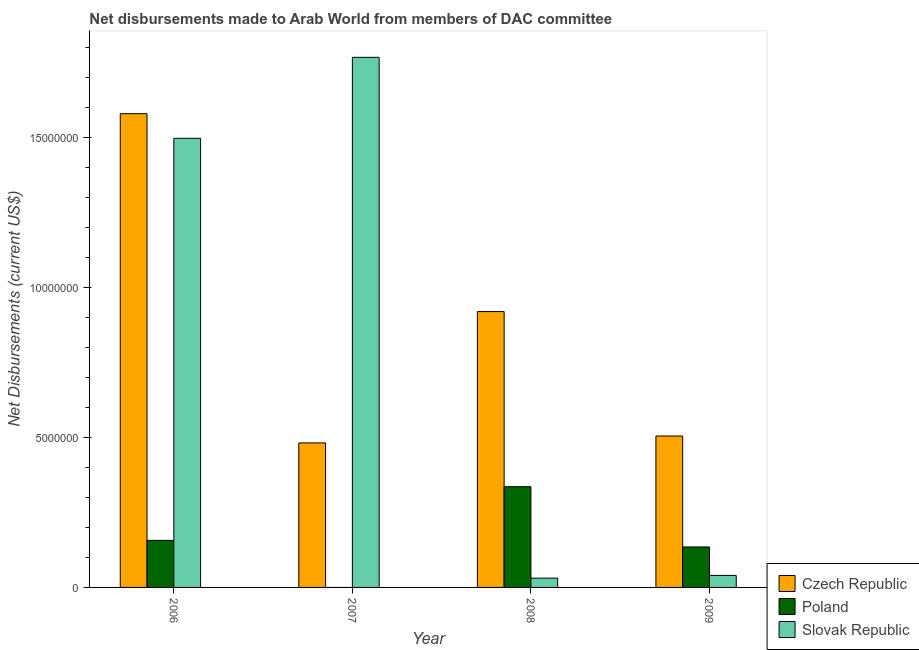How many different coloured bars are there?
Ensure brevity in your answer.  3. How many bars are there on the 3rd tick from the left?
Give a very brief answer. 3. How many bars are there on the 1st tick from the right?
Your answer should be very brief. 3. What is the label of the 3rd group of bars from the left?
Give a very brief answer. 2008. Across all years, what is the maximum net disbursements made by slovak republic?
Offer a very short reply. 1.77e+07. Across all years, what is the minimum net disbursements made by poland?
Provide a succinct answer. 0. In which year was the net disbursements made by czech republic maximum?
Keep it short and to the point. 2006. What is the total net disbursements made by czech republic in the graph?
Your response must be concise. 3.49e+07. What is the difference between the net disbursements made by slovak republic in 2007 and that in 2008?
Offer a very short reply. 1.74e+07. What is the difference between the net disbursements made by slovak republic in 2006 and the net disbursements made by poland in 2008?
Offer a terse response. 1.47e+07. What is the average net disbursements made by czech republic per year?
Ensure brevity in your answer.  8.72e+06. What is the ratio of the net disbursements made by slovak republic in 2006 to that in 2007?
Provide a succinct answer. 0.85. Is the net disbursements made by slovak republic in 2006 less than that in 2009?
Give a very brief answer. No. Is the difference between the net disbursements made by czech republic in 2006 and 2009 greater than the difference between the net disbursements made by slovak republic in 2006 and 2009?
Offer a terse response. No. What is the difference between the highest and the second highest net disbursements made by slovak republic?
Ensure brevity in your answer.  2.70e+06. What is the difference between the highest and the lowest net disbursements made by slovak republic?
Give a very brief answer. 1.74e+07. In how many years, is the net disbursements made by czech republic greater than the average net disbursements made by czech republic taken over all years?
Offer a very short reply. 2. Is the sum of the net disbursements made by slovak republic in 2006 and 2007 greater than the maximum net disbursements made by poland across all years?
Your answer should be compact. Yes. Are all the bars in the graph horizontal?
Provide a short and direct response. No. How many years are there in the graph?
Ensure brevity in your answer.  4. Are the values on the major ticks of Y-axis written in scientific E-notation?
Provide a succinct answer. No. Does the graph contain any zero values?
Your answer should be compact. Yes. Does the graph contain grids?
Your answer should be very brief. No. What is the title of the graph?
Keep it short and to the point. Net disbursements made to Arab World from members of DAC committee. What is the label or title of the Y-axis?
Ensure brevity in your answer.  Net Disbursements (current US$). What is the Net Disbursements (current US$) in Czech Republic in 2006?
Your answer should be very brief. 1.58e+07. What is the Net Disbursements (current US$) in Poland in 2006?
Provide a succinct answer. 1.57e+06. What is the Net Disbursements (current US$) of Slovak Republic in 2006?
Your answer should be compact. 1.50e+07. What is the Net Disbursements (current US$) in Czech Republic in 2007?
Your answer should be very brief. 4.82e+06. What is the Net Disbursements (current US$) in Poland in 2007?
Give a very brief answer. 0. What is the Net Disbursements (current US$) of Slovak Republic in 2007?
Your answer should be compact. 1.77e+07. What is the Net Disbursements (current US$) in Czech Republic in 2008?
Keep it short and to the point. 9.20e+06. What is the Net Disbursements (current US$) in Poland in 2008?
Provide a succinct answer. 3.36e+06. What is the Net Disbursements (current US$) of Slovak Republic in 2008?
Offer a very short reply. 3.10e+05. What is the Net Disbursements (current US$) in Czech Republic in 2009?
Your response must be concise. 5.05e+06. What is the Net Disbursements (current US$) of Poland in 2009?
Make the answer very short. 1.35e+06. Across all years, what is the maximum Net Disbursements (current US$) of Czech Republic?
Ensure brevity in your answer.  1.58e+07. Across all years, what is the maximum Net Disbursements (current US$) of Poland?
Provide a succinct answer. 3.36e+06. Across all years, what is the maximum Net Disbursements (current US$) of Slovak Republic?
Your answer should be compact. 1.77e+07. Across all years, what is the minimum Net Disbursements (current US$) of Czech Republic?
Make the answer very short. 4.82e+06. Across all years, what is the minimum Net Disbursements (current US$) of Slovak Republic?
Your answer should be compact. 3.10e+05. What is the total Net Disbursements (current US$) of Czech Republic in the graph?
Offer a terse response. 3.49e+07. What is the total Net Disbursements (current US$) of Poland in the graph?
Make the answer very short. 6.28e+06. What is the total Net Disbursements (current US$) of Slovak Republic in the graph?
Keep it short and to the point. 3.34e+07. What is the difference between the Net Disbursements (current US$) of Czech Republic in 2006 and that in 2007?
Ensure brevity in your answer.  1.10e+07. What is the difference between the Net Disbursements (current US$) in Slovak Republic in 2006 and that in 2007?
Provide a short and direct response. -2.70e+06. What is the difference between the Net Disbursements (current US$) in Czech Republic in 2006 and that in 2008?
Make the answer very short. 6.60e+06. What is the difference between the Net Disbursements (current US$) in Poland in 2006 and that in 2008?
Provide a succinct answer. -1.79e+06. What is the difference between the Net Disbursements (current US$) in Slovak Republic in 2006 and that in 2008?
Keep it short and to the point. 1.47e+07. What is the difference between the Net Disbursements (current US$) of Czech Republic in 2006 and that in 2009?
Keep it short and to the point. 1.08e+07. What is the difference between the Net Disbursements (current US$) in Poland in 2006 and that in 2009?
Ensure brevity in your answer.  2.20e+05. What is the difference between the Net Disbursements (current US$) of Slovak Republic in 2006 and that in 2009?
Provide a short and direct response. 1.46e+07. What is the difference between the Net Disbursements (current US$) of Czech Republic in 2007 and that in 2008?
Offer a terse response. -4.38e+06. What is the difference between the Net Disbursements (current US$) of Slovak Republic in 2007 and that in 2008?
Ensure brevity in your answer.  1.74e+07. What is the difference between the Net Disbursements (current US$) in Slovak Republic in 2007 and that in 2009?
Offer a very short reply. 1.73e+07. What is the difference between the Net Disbursements (current US$) in Czech Republic in 2008 and that in 2009?
Make the answer very short. 4.15e+06. What is the difference between the Net Disbursements (current US$) in Poland in 2008 and that in 2009?
Your answer should be very brief. 2.01e+06. What is the difference between the Net Disbursements (current US$) of Czech Republic in 2006 and the Net Disbursements (current US$) of Slovak Republic in 2007?
Provide a succinct answer. -1.88e+06. What is the difference between the Net Disbursements (current US$) of Poland in 2006 and the Net Disbursements (current US$) of Slovak Republic in 2007?
Your response must be concise. -1.61e+07. What is the difference between the Net Disbursements (current US$) of Czech Republic in 2006 and the Net Disbursements (current US$) of Poland in 2008?
Your answer should be compact. 1.24e+07. What is the difference between the Net Disbursements (current US$) in Czech Republic in 2006 and the Net Disbursements (current US$) in Slovak Republic in 2008?
Ensure brevity in your answer.  1.55e+07. What is the difference between the Net Disbursements (current US$) in Poland in 2006 and the Net Disbursements (current US$) in Slovak Republic in 2008?
Keep it short and to the point. 1.26e+06. What is the difference between the Net Disbursements (current US$) in Czech Republic in 2006 and the Net Disbursements (current US$) in Poland in 2009?
Ensure brevity in your answer.  1.44e+07. What is the difference between the Net Disbursements (current US$) in Czech Republic in 2006 and the Net Disbursements (current US$) in Slovak Republic in 2009?
Offer a very short reply. 1.54e+07. What is the difference between the Net Disbursements (current US$) in Poland in 2006 and the Net Disbursements (current US$) in Slovak Republic in 2009?
Your answer should be compact. 1.17e+06. What is the difference between the Net Disbursements (current US$) in Czech Republic in 2007 and the Net Disbursements (current US$) in Poland in 2008?
Your answer should be compact. 1.46e+06. What is the difference between the Net Disbursements (current US$) in Czech Republic in 2007 and the Net Disbursements (current US$) in Slovak Republic in 2008?
Make the answer very short. 4.51e+06. What is the difference between the Net Disbursements (current US$) in Czech Republic in 2007 and the Net Disbursements (current US$) in Poland in 2009?
Give a very brief answer. 3.47e+06. What is the difference between the Net Disbursements (current US$) of Czech Republic in 2007 and the Net Disbursements (current US$) of Slovak Republic in 2009?
Make the answer very short. 4.42e+06. What is the difference between the Net Disbursements (current US$) of Czech Republic in 2008 and the Net Disbursements (current US$) of Poland in 2009?
Provide a succinct answer. 7.85e+06. What is the difference between the Net Disbursements (current US$) of Czech Republic in 2008 and the Net Disbursements (current US$) of Slovak Republic in 2009?
Keep it short and to the point. 8.80e+06. What is the difference between the Net Disbursements (current US$) in Poland in 2008 and the Net Disbursements (current US$) in Slovak Republic in 2009?
Provide a short and direct response. 2.96e+06. What is the average Net Disbursements (current US$) in Czech Republic per year?
Keep it short and to the point. 8.72e+06. What is the average Net Disbursements (current US$) in Poland per year?
Keep it short and to the point. 1.57e+06. What is the average Net Disbursements (current US$) of Slovak Republic per year?
Your answer should be very brief. 8.34e+06. In the year 2006, what is the difference between the Net Disbursements (current US$) of Czech Republic and Net Disbursements (current US$) of Poland?
Make the answer very short. 1.42e+07. In the year 2006, what is the difference between the Net Disbursements (current US$) in Czech Republic and Net Disbursements (current US$) in Slovak Republic?
Give a very brief answer. 8.20e+05. In the year 2006, what is the difference between the Net Disbursements (current US$) of Poland and Net Disbursements (current US$) of Slovak Republic?
Your response must be concise. -1.34e+07. In the year 2007, what is the difference between the Net Disbursements (current US$) of Czech Republic and Net Disbursements (current US$) of Slovak Republic?
Give a very brief answer. -1.29e+07. In the year 2008, what is the difference between the Net Disbursements (current US$) of Czech Republic and Net Disbursements (current US$) of Poland?
Offer a very short reply. 5.84e+06. In the year 2008, what is the difference between the Net Disbursements (current US$) in Czech Republic and Net Disbursements (current US$) in Slovak Republic?
Offer a very short reply. 8.89e+06. In the year 2008, what is the difference between the Net Disbursements (current US$) in Poland and Net Disbursements (current US$) in Slovak Republic?
Your answer should be compact. 3.05e+06. In the year 2009, what is the difference between the Net Disbursements (current US$) of Czech Republic and Net Disbursements (current US$) of Poland?
Give a very brief answer. 3.70e+06. In the year 2009, what is the difference between the Net Disbursements (current US$) in Czech Republic and Net Disbursements (current US$) in Slovak Republic?
Offer a very short reply. 4.65e+06. In the year 2009, what is the difference between the Net Disbursements (current US$) of Poland and Net Disbursements (current US$) of Slovak Republic?
Keep it short and to the point. 9.50e+05. What is the ratio of the Net Disbursements (current US$) in Czech Republic in 2006 to that in 2007?
Make the answer very short. 3.28. What is the ratio of the Net Disbursements (current US$) of Slovak Republic in 2006 to that in 2007?
Your answer should be compact. 0.85. What is the ratio of the Net Disbursements (current US$) in Czech Republic in 2006 to that in 2008?
Provide a short and direct response. 1.72. What is the ratio of the Net Disbursements (current US$) of Poland in 2006 to that in 2008?
Your answer should be compact. 0.47. What is the ratio of the Net Disbursements (current US$) in Slovak Republic in 2006 to that in 2008?
Keep it short and to the point. 48.32. What is the ratio of the Net Disbursements (current US$) in Czech Republic in 2006 to that in 2009?
Ensure brevity in your answer.  3.13. What is the ratio of the Net Disbursements (current US$) in Poland in 2006 to that in 2009?
Keep it short and to the point. 1.16. What is the ratio of the Net Disbursements (current US$) in Slovak Republic in 2006 to that in 2009?
Offer a terse response. 37.45. What is the ratio of the Net Disbursements (current US$) of Czech Republic in 2007 to that in 2008?
Make the answer very short. 0.52. What is the ratio of the Net Disbursements (current US$) in Slovak Republic in 2007 to that in 2008?
Ensure brevity in your answer.  57.03. What is the ratio of the Net Disbursements (current US$) of Czech Republic in 2007 to that in 2009?
Keep it short and to the point. 0.95. What is the ratio of the Net Disbursements (current US$) in Slovak Republic in 2007 to that in 2009?
Give a very brief answer. 44.2. What is the ratio of the Net Disbursements (current US$) of Czech Republic in 2008 to that in 2009?
Your response must be concise. 1.82. What is the ratio of the Net Disbursements (current US$) in Poland in 2008 to that in 2009?
Give a very brief answer. 2.49. What is the ratio of the Net Disbursements (current US$) of Slovak Republic in 2008 to that in 2009?
Provide a short and direct response. 0.78. What is the difference between the highest and the second highest Net Disbursements (current US$) of Czech Republic?
Offer a very short reply. 6.60e+06. What is the difference between the highest and the second highest Net Disbursements (current US$) in Poland?
Give a very brief answer. 1.79e+06. What is the difference between the highest and the second highest Net Disbursements (current US$) of Slovak Republic?
Your answer should be very brief. 2.70e+06. What is the difference between the highest and the lowest Net Disbursements (current US$) in Czech Republic?
Provide a short and direct response. 1.10e+07. What is the difference between the highest and the lowest Net Disbursements (current US$) of Poland?
Ensure brevity in your answer.  3.36e+06. What is the difference between the highest and the lowest Net Disbursements (current US$) of Slovak Republic?
Provide a short and direct response. 1.74e+07. 